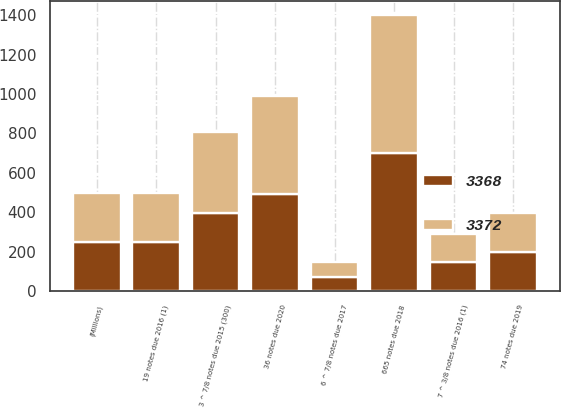<chart> <loc_0><loc_0><loc_500><loc_500><stacked_bar_chart><ecel><fcel>(Millions)<fcel>3 ^ 7/8 notes due 2015 (300)<fcel>19 notes due 2016 (1)<fcel>7 ^ 3/8 notes due 2016 (1)<fcel>6 ^ 7/8 notes due 2017<fcel>665 notes due 2018<fcel>74 notes due 2019<fcel>36 notes due 2020<nl><fcel>3372<fcel>249<fcel>413<fcel>249<fcel>146<fcel>74<fcel>700<fcel>198<fcel>495<nl><fcel>3368<fcel>249<fcel>395<fcel>249<fcel>146<fcel>74<fcel>700<fcel>198<fcel>495<nl></chart> 